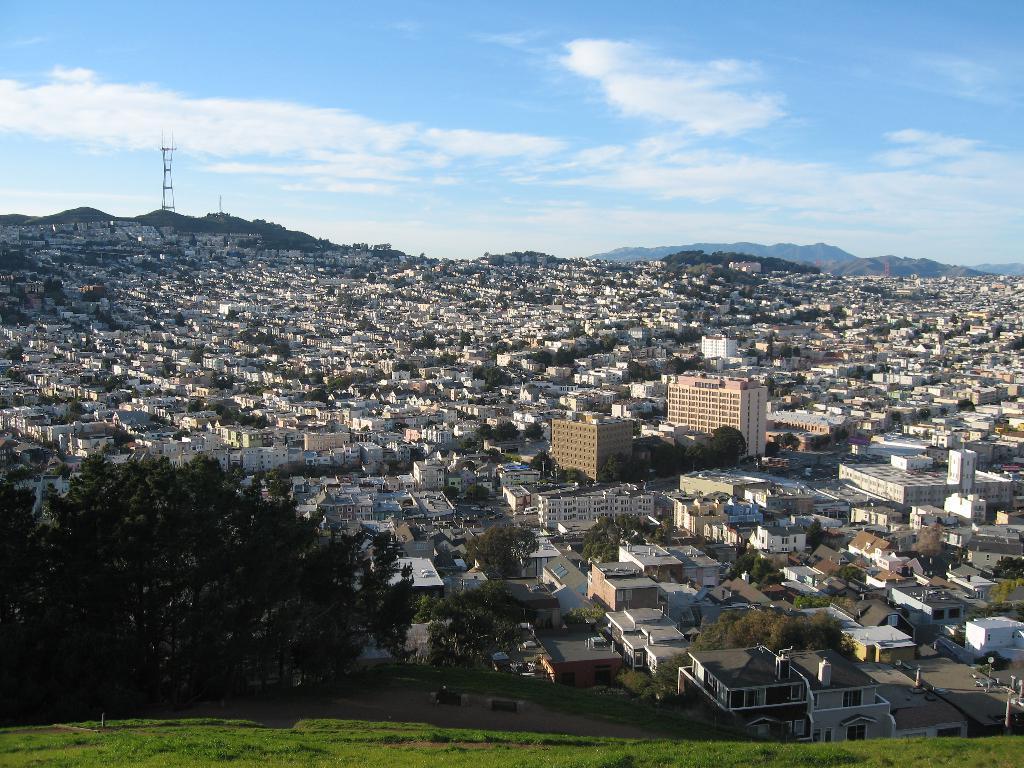Please provide a concise description of this image. In this image, I can see the view of the city. These are the houses and buildings. I can see the trees. This looks like a tower. In the background, I think these are the hills. I can see the clouds in the sky. At the bottom of the image, this is the grass. 